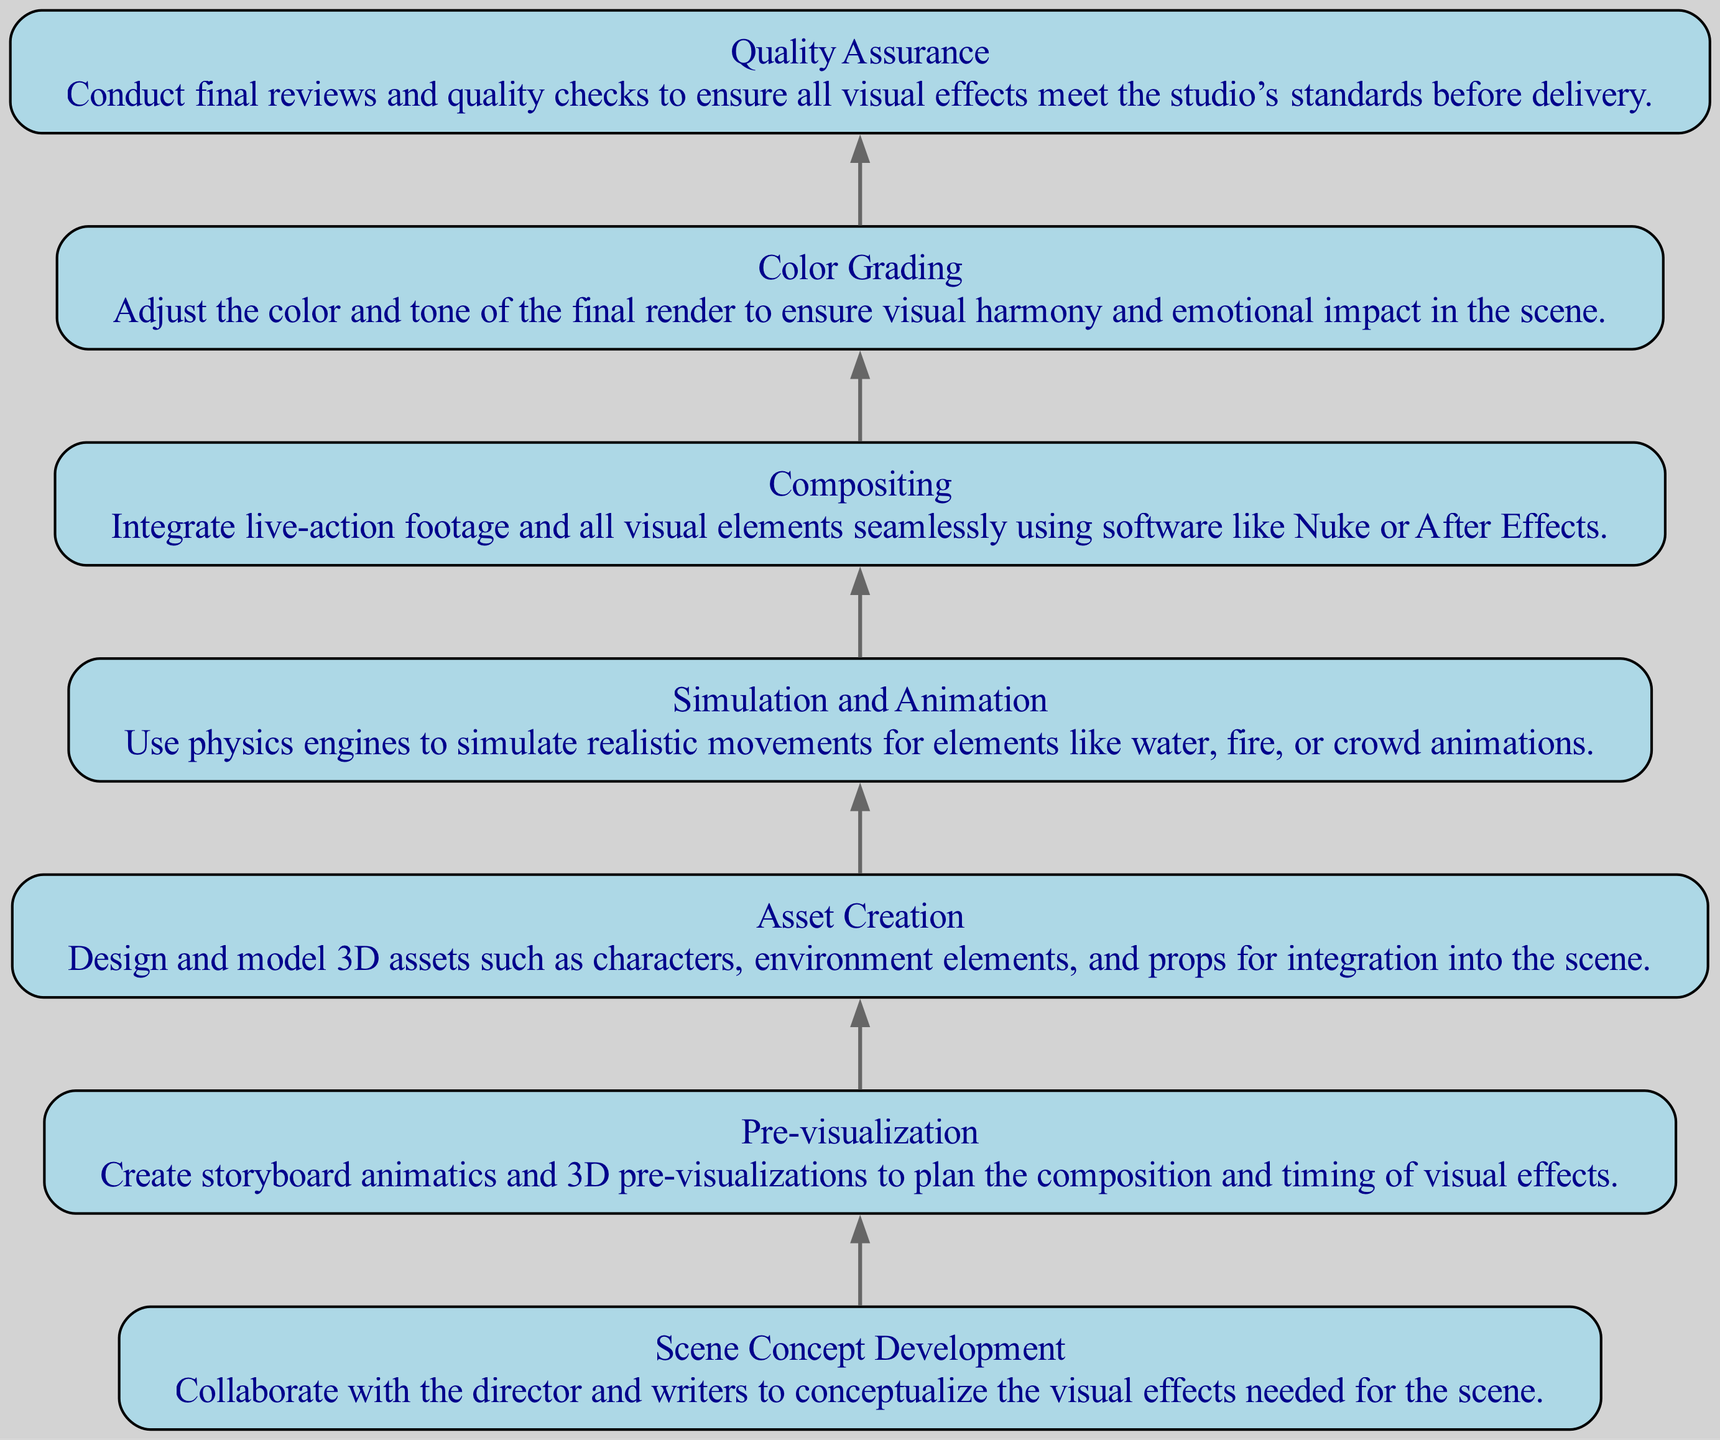What is the first task in the diagram? The first task listed in the diagram is "Scene Concept Development". It is the first element (node) in the flow, indicating the starting point for the visual effects breakdown process.
Answer: Scene Concept Development How many tasks are represented in the diagram? The diagram contains seven distinct tasks or nodes, based on the provided data, indicating the key steps in visual effects for a specific scene.
Answer: 7 What is the last task in the flowchart? The last task in the diagram is "Quality Assurance". It is positioned at the end of the flow, showing that it is the final step in the visual effects process before delivery.
Answer: Quality Assurance Which task directly follows "Asset Creation"? "Simulation and Animation" directly follows "Asset Creation" in the flow, showing the sequential steps in the visual effects process.
Answer: Simulation and Animation What relationship exists between "Pre-visualization" and "Compositing"? There is no direct edge between "Pre-visualization" and "Compositing", indicating that they are separate tasks in the flow, but "Pre-visualization" is an earlier step followed by "Asset Creation" before reaching "Compositing".
Answer: No direct relationship How many tasks involve animation processes? There are two tasks involving animation processes: "Simulation and Animation" and "Color Grading". Both tasks relate to the motion of visual elements in the scene.
Answer: 2 What is the primary purpose of "Color Grading"? The primary purpose of "Color Grading" is to adjust the color and tone of the final render to ensure visual harmony and emotional impact in the scene, enhancing the overall aesthetic.
Answer: Adjust color and tone Which task precedes "Compositing" in the flowchart? The task that precedes "Compositing" is "Asset Creation". This shows the chronological flow of work where assets are created before they are composited into the final scene.
Answer: Asset Creation What is the main focus of the "Quality Assurance" task? The main focus of the "Quality Assurance" task is to conduct final reviews and quality checks of all visual effects to ensure they meet the studio’s standards.
Answer: Final reviews and quality checks 